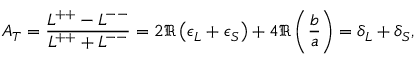<formula> <loc_0><loc_0><loc_500><loc_500>A _ { T } = \frac { L ^ { + + } - L ^ { - - } } { L ^ { + + } + L ^ { - - } } = 2 \Re \left ( \epsilon _ { L } + \epsilon _ { S } \right ) + 4 \Re \left ( \frac { b } { a } \right ) = \delta _ { L } + \delta _ { S } ,</formula> 